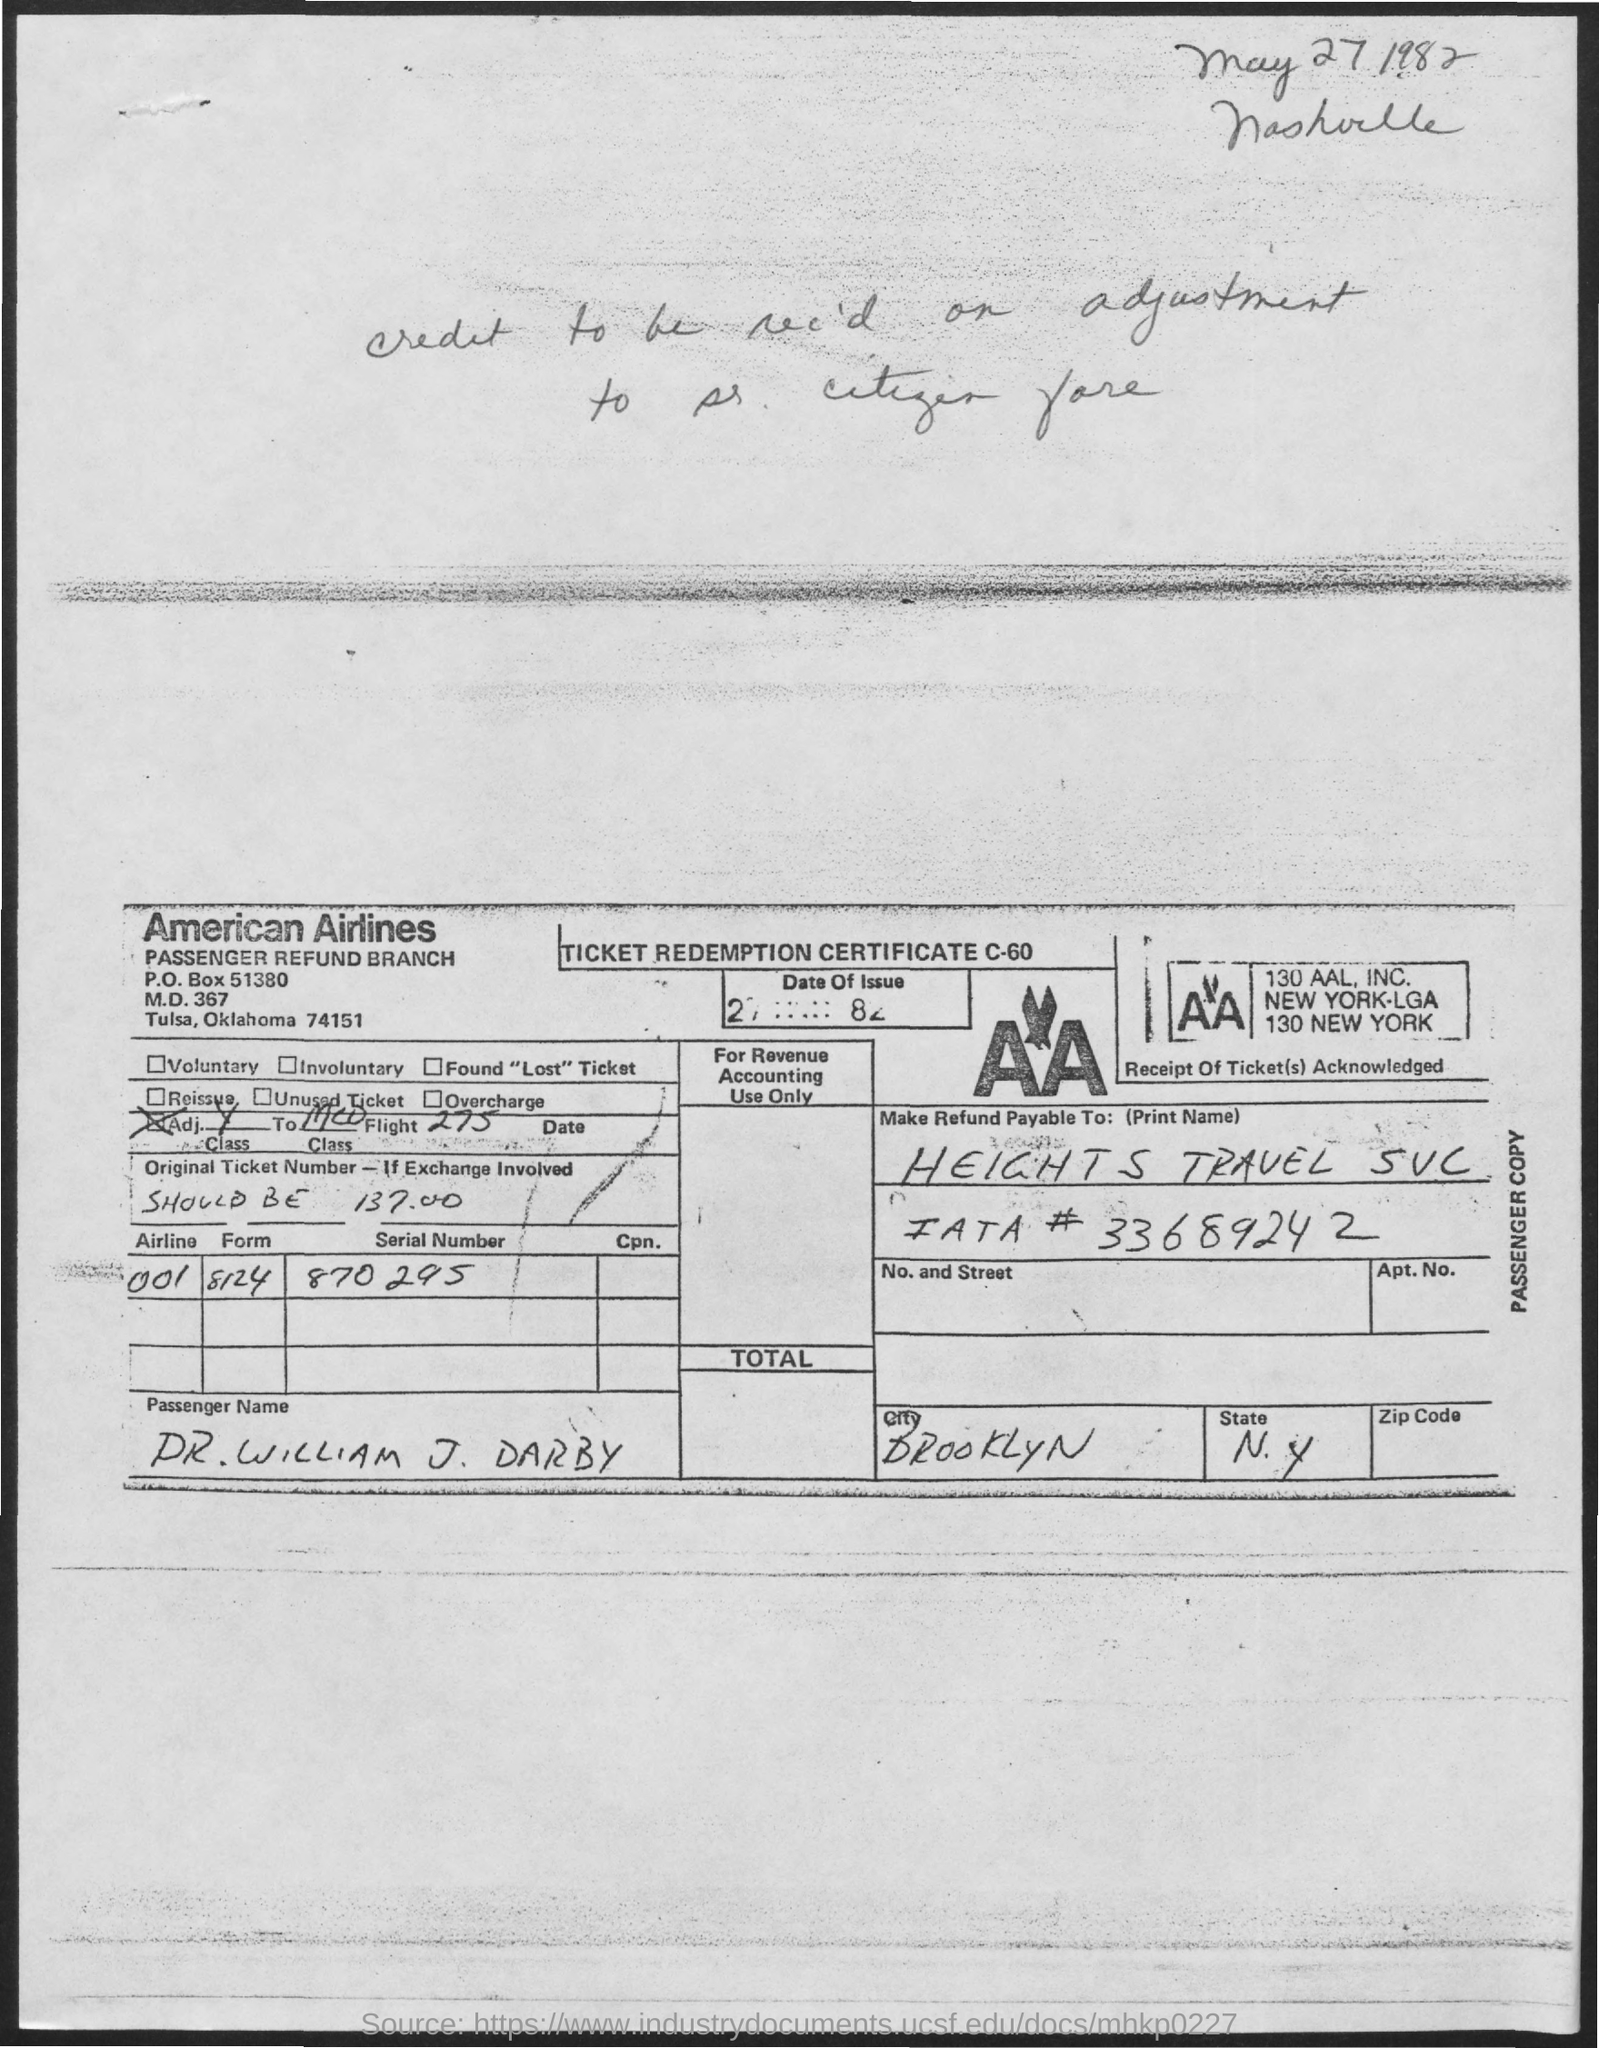List a handful of essential elements in this visual. The state whose name is written as "n.y." is being referred to. The PO Box number mentioned in the document is 51380. The serial number is 870295... The city whose name is Brooklyn is located in the United States. The form number is 8124. 